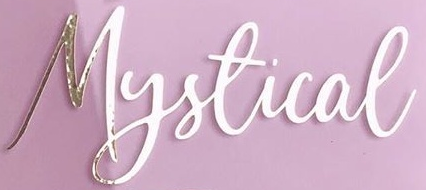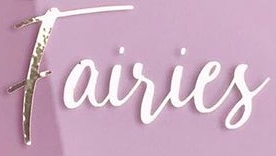Identify the words shown in these images in order, separated by a semicolon. Mystical; Fairies 